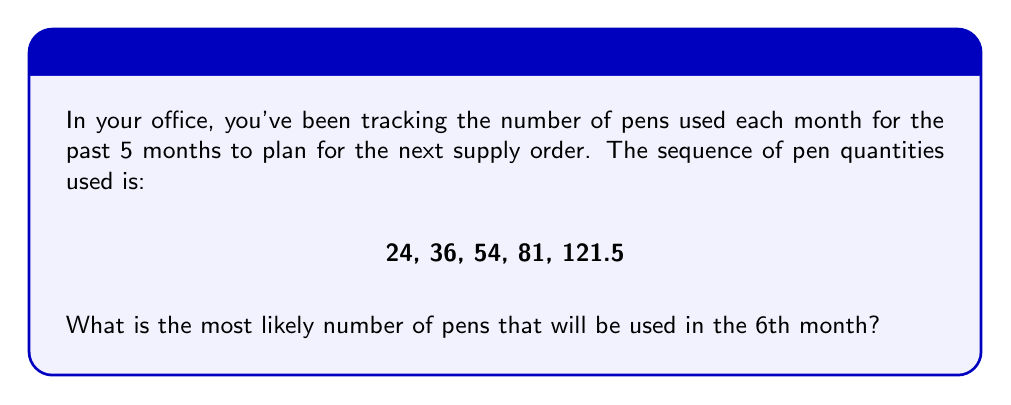What is the answer to this math problem? Let's approach this step-by-step:

1) First, we need to identify the pattern in the sequence. Let's look at the ratio between consecutive terms:

   $\frac{36}{24} = 1.5$
   $\frac{54}{36} = 1.5$
   $\frac{81}{54} = 1.5$
   $\frac{121.5}{81} = 1.5$

2) We can see that each term is 1.5 times the previous term. This is a geometric sequence with a common ratio of 1.5.

3) In a geometric sequence, each term can be expressed as:

   $a_n = a_1 \cdot r^{n-1}$

   Where $a_n$ is the nth term, $a_1$ is the first term, and $r$ is the common ratio.

4) In this case, $a_1 = 24$ and $r = 1.5$

5) To find the 6th term, we use $n = 6$:

   $a_6 = 24 \cdot (1.5)^{6-1}$
   $a_6 = 24 \cdot (1.5)^5$

6) Calculate:
   $a_6 = 24 \cdot 7.59375 = 182.25$

Therefore, based on the pattern, 182.25 pens are likely to be used in the 6th month.
Answer: 182.25 